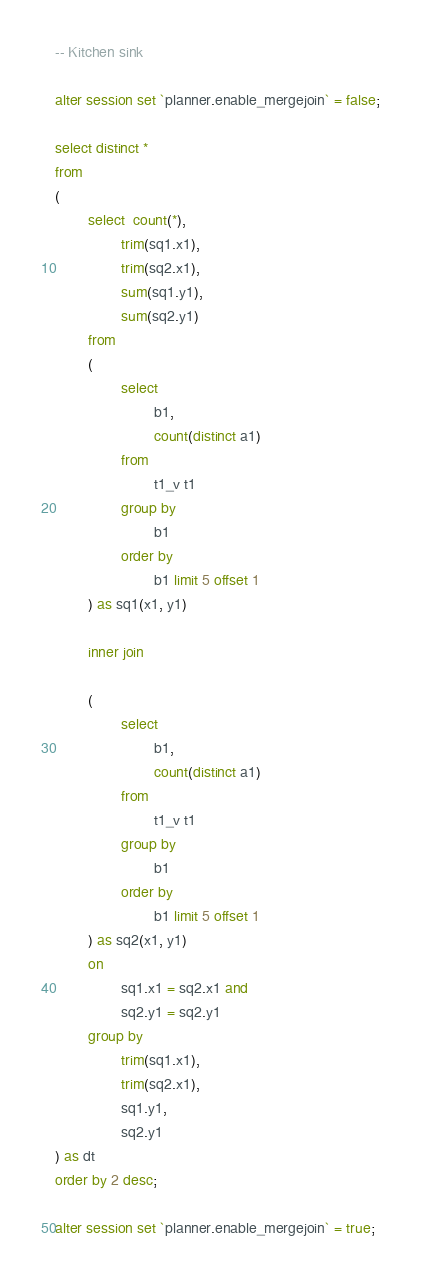<code> <loc_0><loc_0><loc_500><loc_500><_SQL_>-- Kitchen sink

alter session set `planner.enable_mergejoin` = false;

select distinct *
from
(
        select  count(*),
                trim(sq1.x1),
                trim(sq2.x1),
                sum(sq1.y1),
                sum(sq2.y1)
        from
        (
                select
                        b1,
                        count(distinct a1)
                from
                        t1_v t1
                group by
                        b1
                order by
                        b1 limit 5 offset 1
        ) as sq1(x1, y1)

        inner join

        (
                select
                        b1,
                        count(distinct a1)
                from
                        t1_v t1
                group by
                        b1
                order by
                        b1 limit 5 offset 1
        ) as sq2(x1, y1)
        on
                sq1.x1 = sq2.x1 and
                sq2.y1 = sq2.y1
        group by
                trim(sq1.x1),
                trim(sq2.x1),
                sq1.y1,
                sq2.y1
) as dt
order by 2 desc;

alter session set `planner.enable_mergejoin` = true;
</code> 